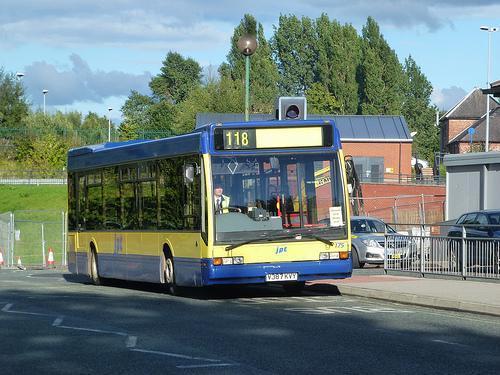How many people are in photo?
Give a very brief answer. 1. 